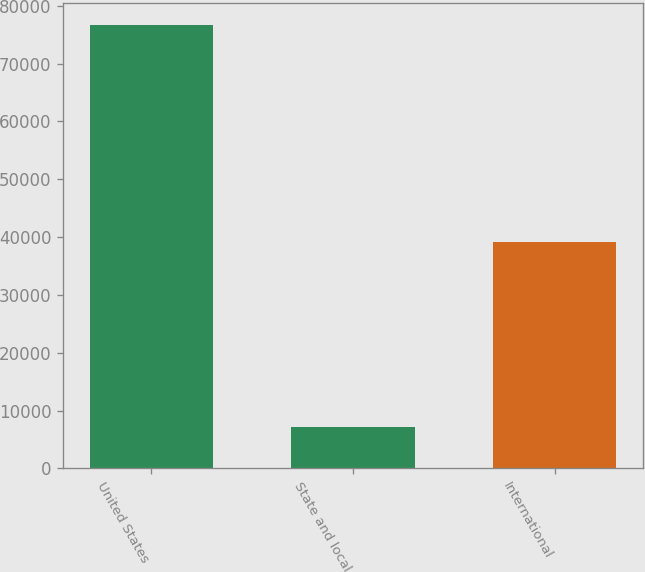Convert chart to OTSL. <chart><loc_0><loc_0><loc_500><loc_500><bar_chart><fcel>United States<fcel>State and local<fcel>International<nl><fcel>76642<fcel>7147<fcel>39081<nl></chart> 